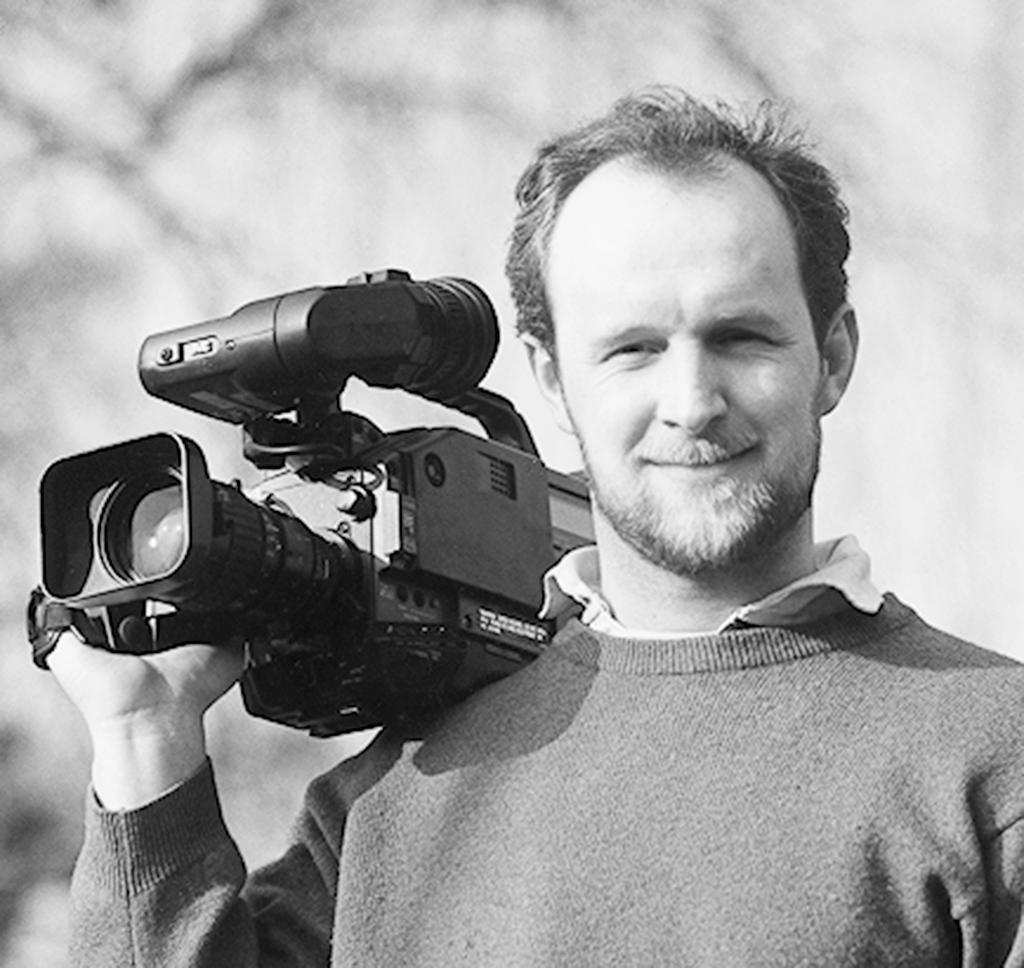How would you summarize this image in a sentence or two? This is a black and white picture. Here we can see a man who is holding a camera with his hand. 